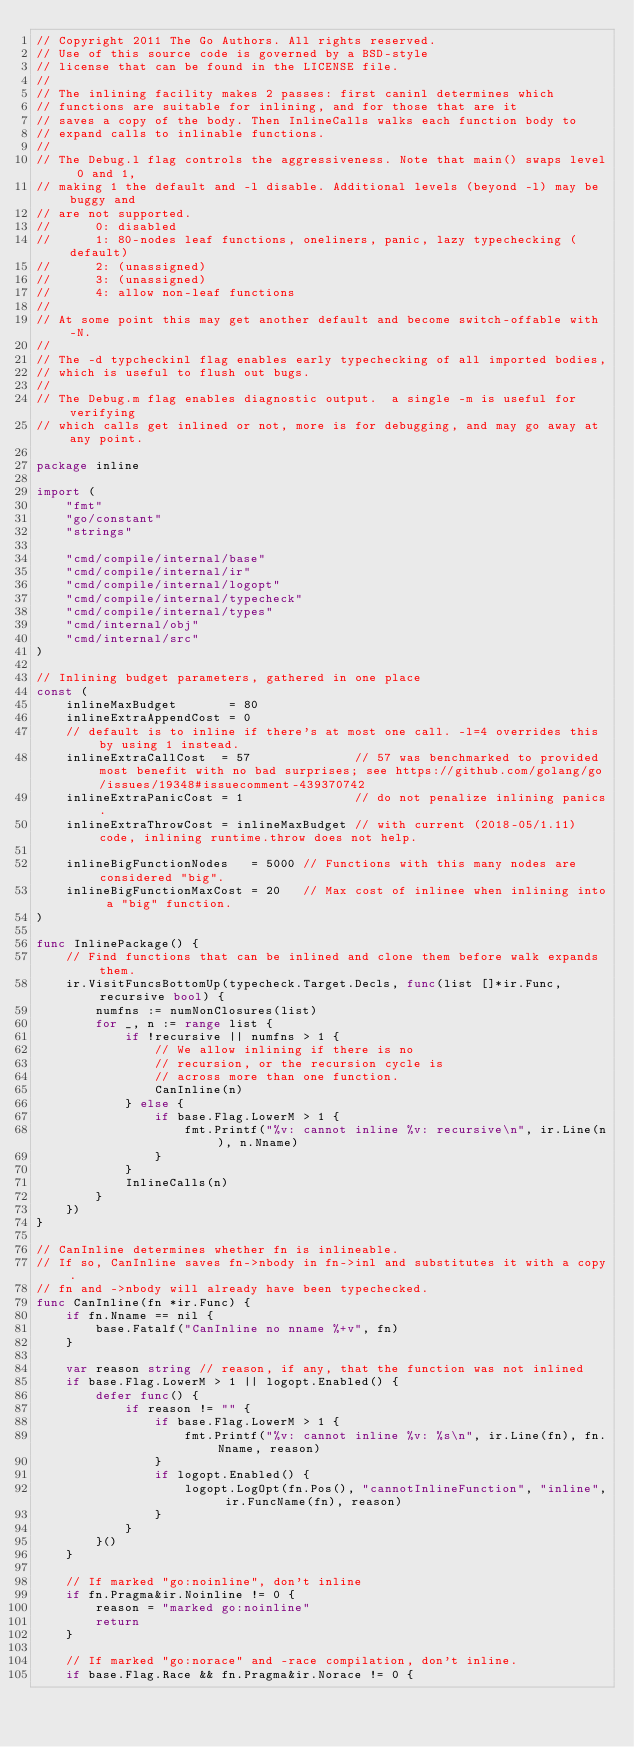Convert code to text. <code><loc_0><loc_0><loc_500><loc_500><_Go_>// Copyright 2011 The Go Authors. All rights reserved.
// Use of this source code is governed by a BSD-style
// license that can be found in the LICENSE file.
//
// The inlining facility makes 2 passes: first caninl determines which
// functions are suitable for inlining, and for those that are it
// saves a copy of the body. Then InlineCalls walks each function body to
// expand calls to inlinable functions.
//
// The Debug.l flag controls the aggressiveness. Note that main() swaps level 0 and 1,
// making 1 the default and -l disable. Additional levels (beyond -l) may be buggy and
// are not supported.
//      0: disabled
//      1: 80-nodes leaf functions, oneliners, panic, lazy typechecking (default)
//      2: (unassigned)
//      3: (unassigned)
//      4: allow non-leaf functions
//
// At some point this may get another default and become switch-offable with -N.
//
// The -d typcheckinl flag enables early typechecking of all imported bodies,
// which is useful to flush out bugs.
//
// The Debug.m flag enables diagnostic output.  a single -m is useful for verifying
// which calls get inlined or not, more is for debugging, and may go away at any point.

package inline

import (
	"fmt"
	"go/constant"
	"strings"

	"cmd/compile/internal/base"
	"cmd/compile/internal/ir"
	"cmd/compile/internal/logopt"
	"cmd/compile/internal/typecheck"
	"cmd/compile/internal/types"
	"cmd/internal/obj"
	"cmd/internal/src"
)

// Inlining budget parameters, gathered in one place
const (
	inlineMaxBudget       = 80
	inlineExtraAppendCost = 0
	// default is to inline if there's at most one call. -l=4 overrides this by using 1 instead.
	inlineExtraCallCost  = 57              // 57 was benchmarked to provided most benefit with no bad surprises; see https://github.com/golang/go/issues/19348#issuecomment-439370742
	inlineExtraPanicCost = 1               // do not penalize inlining panics.
	inlineExtraThrowCost = inlineMaxBudget // with current (2018-05/1.11) code, inlining runtime.throw does not help.

	inlineBigFunctionNodes   = 5000 // Functions with this many nodes are considered "big".
	inlineBigFunctionMaxCost = 20   // Max cost of inlinee when inlining into a "big" function.
)

func InlinePackage() {
	// Find functions that can be inlined and clone them before walk expands them.
	ir.VisitFuncsBottomUp(typecheck.Target.Decls, func(list []*ir.Func, recursive bool) {
		numfns := numNonClosures(list)
		for _, n := range list {
			if !recursive || numfns > 1 {
				// We allow inlining if there is no
				// recursion, or the recursion cycle is
				// across more than one function.
				CanInline(n)
			} else {
				if base.Flag.LowerM > 1 {
					fmt.Printf("%v: cannot inline %v: recursive\n", ir.Line(n), n.Nname)
				}
			}
			InlineCalls(n)
		}
	})
}

// CanInline determines whether fn is inlineable.
// If so, CanInline saves fn->nbody in fn->inl and substitutes it with a copy.
// fn and ->nbody will already have been typechecked.
func CanInline(fn *ir.Func) {
	if fn.Nname == nil {
		base.Fatalf("CanInline no nname %+v", fn)
	}

	var reason string // reason, if any, that the function was not inlined
	if base.Flag.LowerM > 1 || logopt.Enabled() {
		defer func() {
			if reason != "" {
				if base.Flag.LowerM > 1 {
					fmt.Printf("%v: cannot inline %v: %s\n", ir.Line(fn), fn.Nname, reason)
				}
				if logopt.Enabled() {
					logopt.LogOpt(fn.Pos(), "cannotInlineFunction", "inline", ir.FuncName(fn), reason)
				}
			}
		}()
	}

	// If marked "go:noinline", don't inline
	if fn.Pragma&ir.Noinline != 0 {
		reason = "marked go:noinline"
		return
	}

	// If marked "go:norace" and -race compilation, don't inline.
	if base.Flag.Race && fn.Pragma&ir.Norace != 0 {</code> 